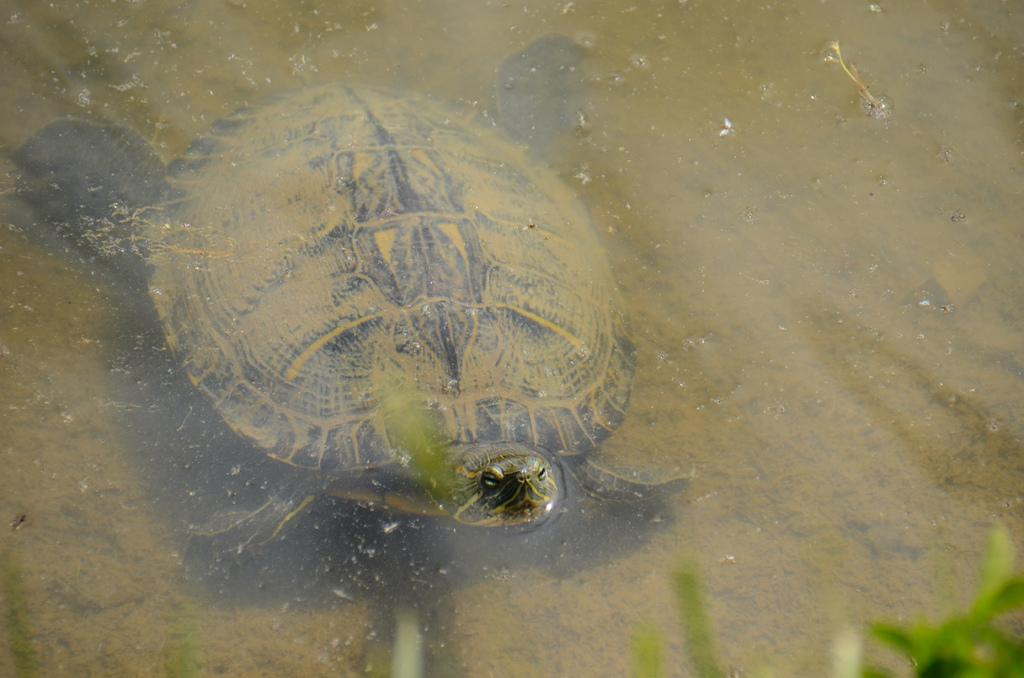What animal can be seen in the image? There is a turtle in the image. What is the turtle doing in the image? The turtle is swimming in the water. Can you describe the environment where the turtle is located? The water might be in a pond, and there are aquatic plants or grass in the right bottom of the image. What type of trouble is the cabbage experiencing in the image? There is no cabbage present in the image, so it cannot be experiencing any trouble. 